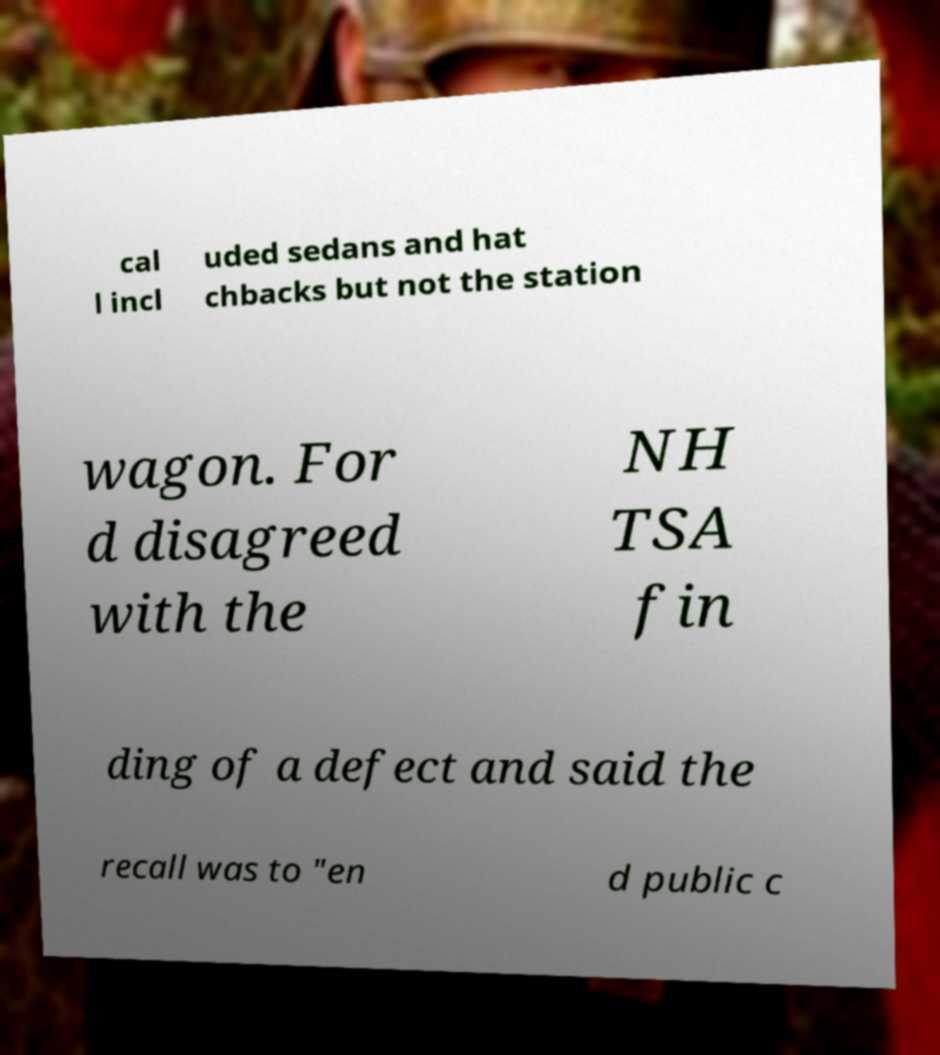Please identify and transcribe the text found in this image. cal l incl uded sedans and hat chbacks but not the station wagon. For d disagreed with the NH TSA fin ding of a defect and said the recall was to "en d public c 